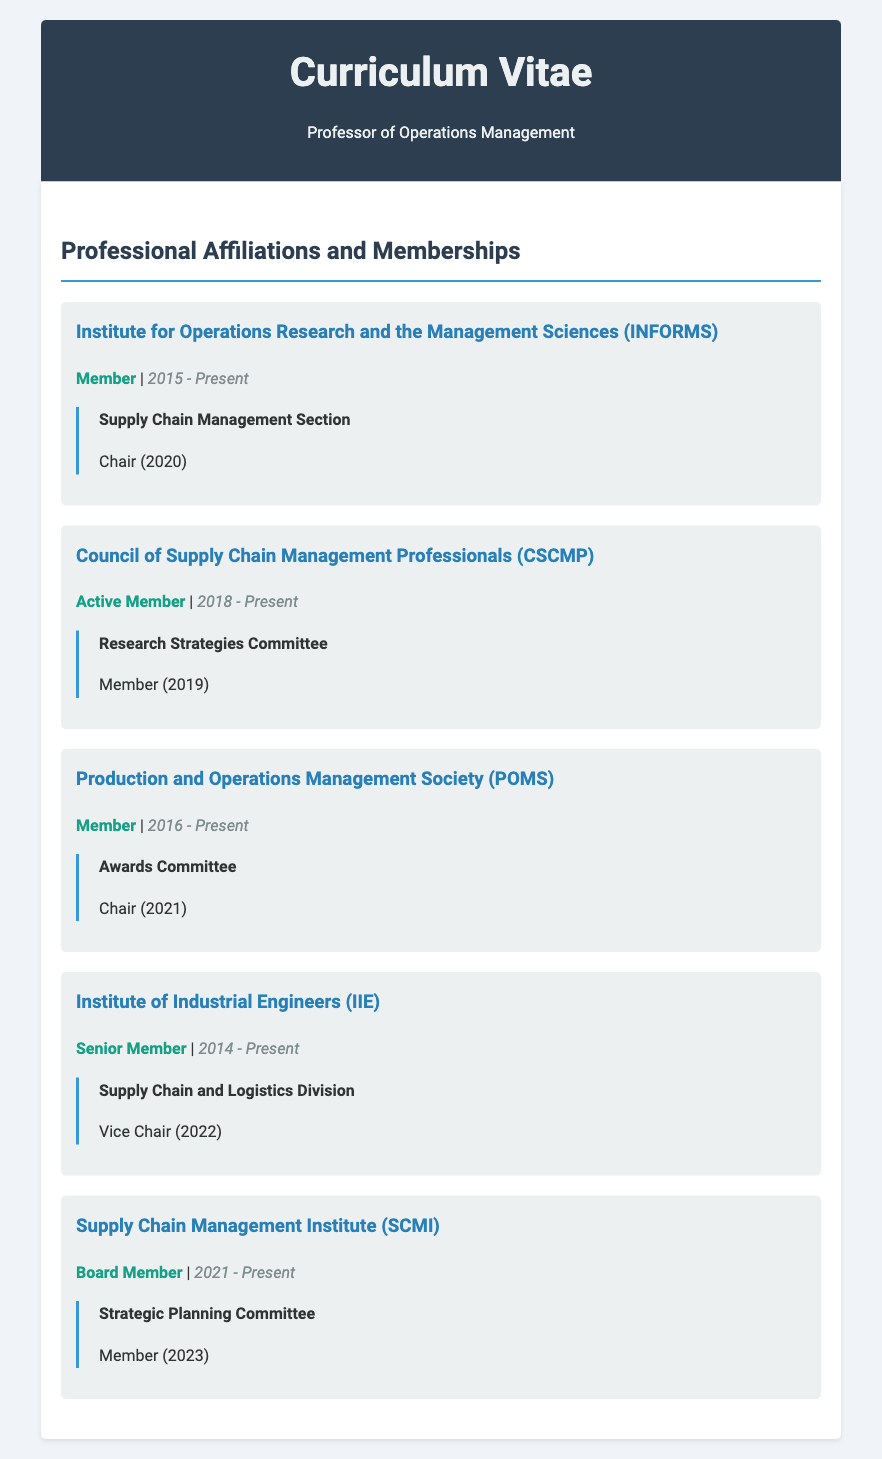What is the current role held in INFORMS? The document states that the current role held in INFORMS is "Member".
Answer: Member In which year did the professor become a member of IIE? The document notes that the membership in IIE started in 2014.
Answer: 2014 How long has the professor been a member of CSCMP? The document indicates that the professor has been an active member of CSCMP since 2018, which is 5 years as of 2023.
Answer: 5 years What position did the professor hold in the POMS Awards Committee? The document mentions that the professor was the "Chair" of the POMS Awards Committee in 2021.
Answer: Chair Which committee is the professor a member of in SCMI? According to the document, the professor is a member of the "Strategic Planning Committee" in SCMI.
Answer: Strategic Planning Committee What are the years of membership in the Production and Operations Management Society? The document indicates that the professor has been a member of POMS from 2016 to the present.
Answer: 2016 - Present How many professional organizations is the professor affiliated with? The document lists a total of five professional organizations.
Answer: Five What role does the professor hold in the Institute of Industrial Engineers? The document states that the professor holds the role of "Senior Member" in IIE.
Answer: Senior Member 